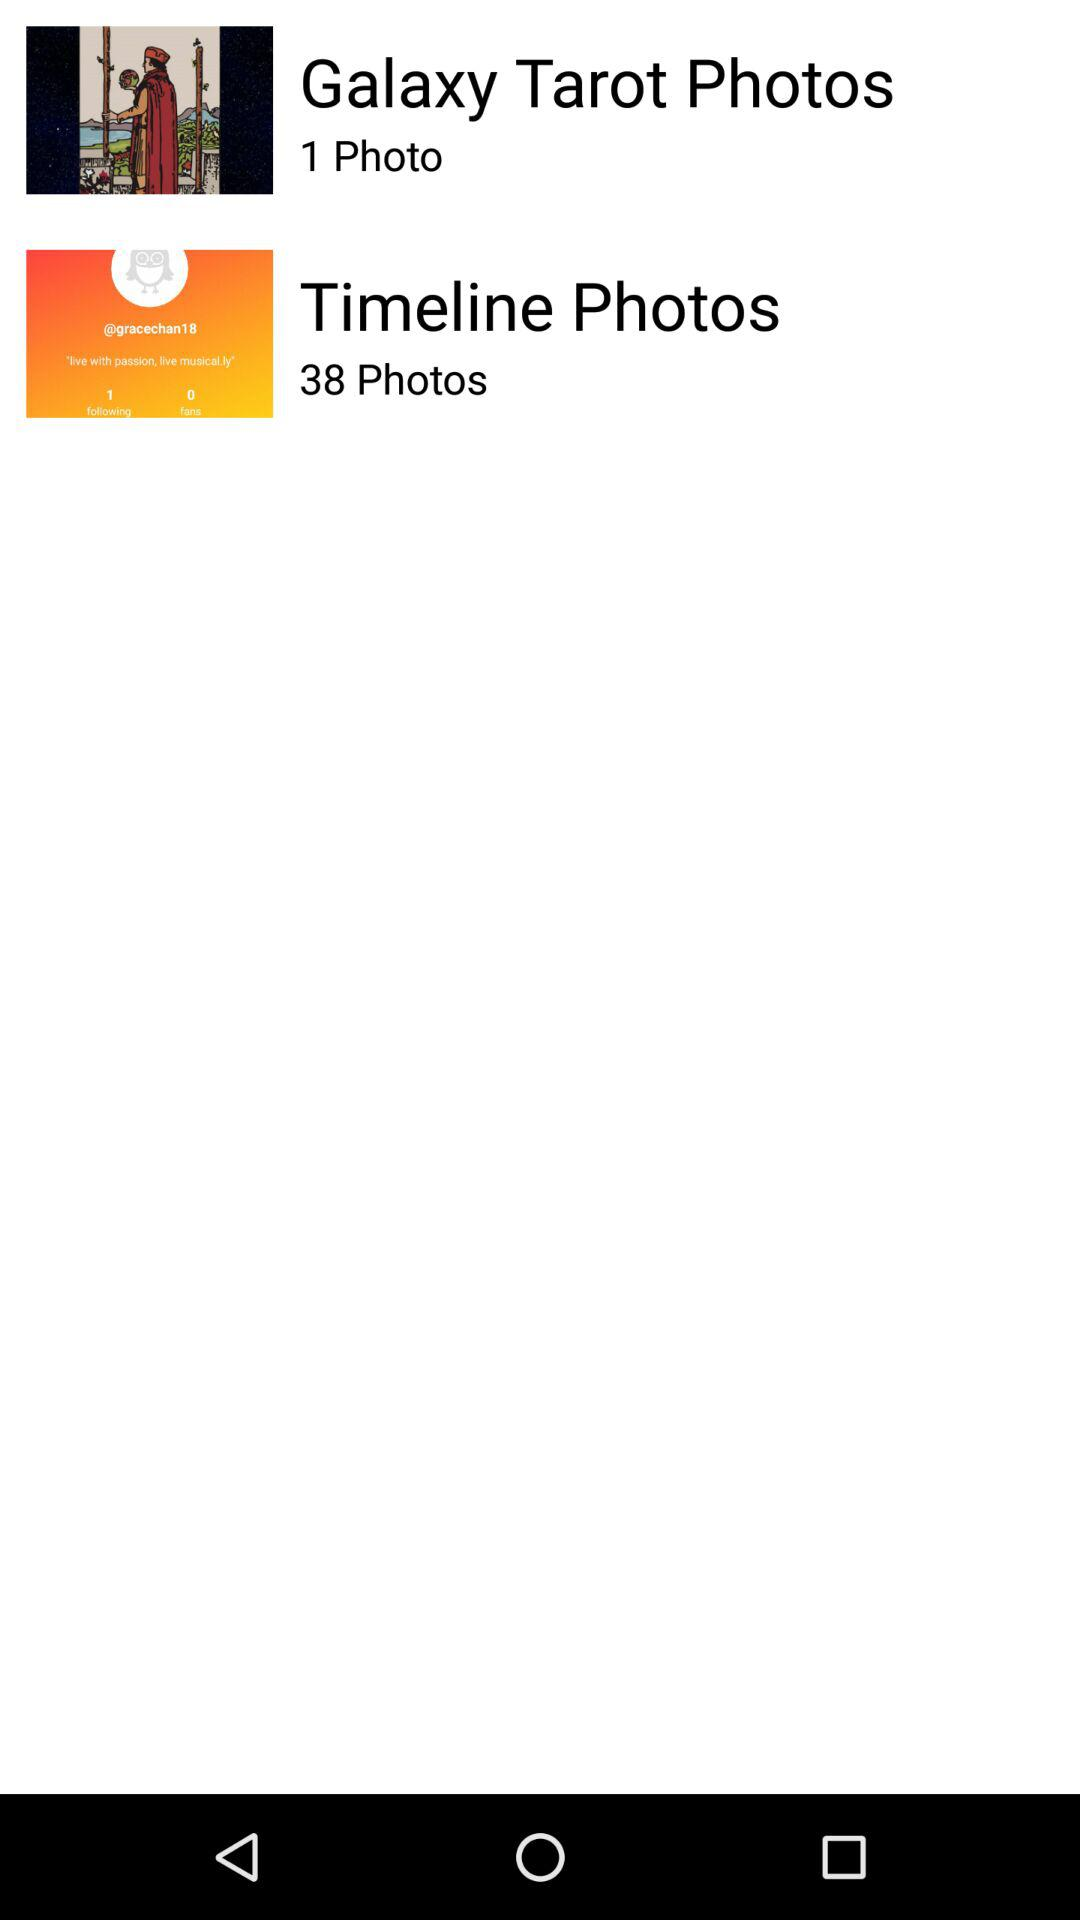How many photos are there in "Galaxy Tarot Photos"? There is 1 photo. 